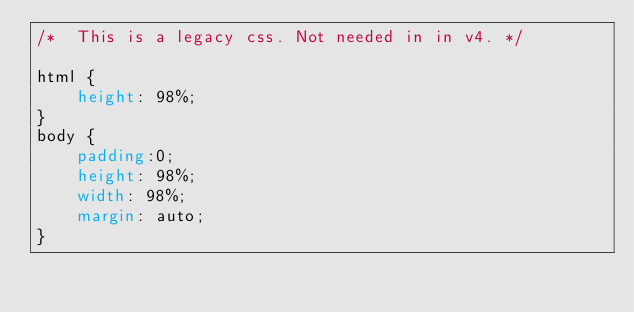<code> <loc_0><loc_0><loc_500><loc_500><_CSS_>/*  This is a legacy css. Not needed in in v4. */

html {
    height: 98%;
}
body {
    padding:0;
    height: 98%;
    width: 98%;
    margin: auto;
}</code> 